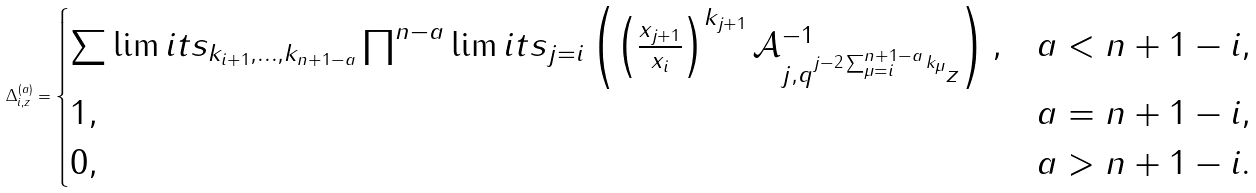Convert formula to latex. <formula><loc_0><loc_0><loc_500><loc_500>\Delta ^ { ( a ) } _ { i , z } = \begin{cases} \sum \lim i t s _ { k _ { i + 1 } , \dots , k _ { n + 1 - a } } \prod ^ { n - a } \lim i t s _ { j = i } \left ( \left ( \frac { x _ { j + 1 } } { x _ { i } } \right ) ^ { k _ { j + 1 } } \mathcal { A } ^ { - 1 } _ { j , q ^ { j - 2 \sum ^ { n + 1 - a } _ { \mu = i } k _ { \mu } } z } \right ) , & a < n + 1 - i , \\ 1 , & a = n + 1 - i , \\ 0 , & a > n + 1 - i . \end{cases}</formula> 